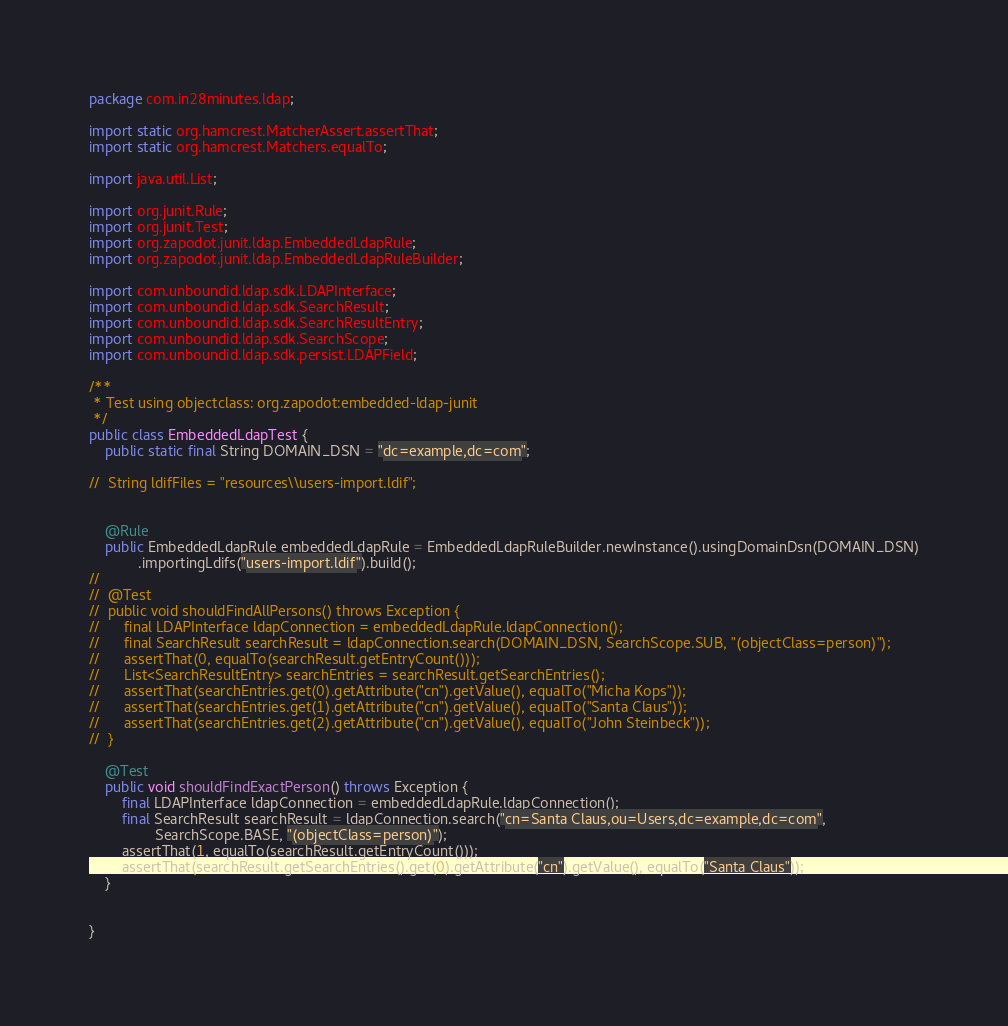Convert code to text. <code><loc_0><loc_0><loc_500><loc_500><_Java_>package com.in28minutes.ldap;

import static org.hamcrest.MatcherAssert.assertThat;
import static org.hamcrest.Matchers.equalTo;

import java.util.List;

import org.junit.Rule;
import org.junit.Test;
import org.zapodot.junit.ldap.EmbeddedLdapRule;
import org.zapodot.junit.ldap.EmbeddedLdapRuleBuilder;

import com.unboundid.ldap.sdk.LDAPInterface;
import com.unboundid.ldap.sdk.SearchResult;
import com.unboundid.ldap.sdk.SearchResultEntry;
import com.unboundid.ldap.sdk.SearchScope;
import com.unboundid.ldap.sdk.persist.LDAPField;

/**
 * Test using objectclass: org.zapodot:embedded-ldap-junit
 */
public class EmbeddedLdapTest {
	public static final String DOMAIN_DSN = "dc=example,dc=com";
	
//	String ldifFiles = "resources\\users-import.ldif";
	
	
	@Rule
	public EmbeddedLdapRule embeddedLdapRule = EmbeddedLdapRuleBuilder.newInstance().usingDomainDsn(DOMAIN_DSN)
			.importingLdifs("users-import.ldif").build();
//
//	@Test
//	public void shouldFindAllPersons() throws Exception {
//		final LDAPInterface ldapConnection = embeddedLdapRule.ldapConnection();
//		final SearchResult searchResult = ldapConnection.search(DOMAIN_DSN, SearchScope.SUB, "(objectClass=person)");
//		assertThat(0, equalTo(searchResult.getEntryCount()));
//		List<SearchResultEntry> searchEntries = searchResult.getSearchEntries();
//		assertThat(searchEntries.get(0).getAttribute("cn").getValue(), equalTo("Micha Kops"));
//		assertThat(searchEntries.get(1).getAttribute("cn").getValue(), equalTo("Santa Claus"));
//		assertThat(searchEntries.get(2).getAttribute("cn").getValue(), equalTo("John Steinbeck"));
//	}

	@Test
	public void shouldFindExactPerson() throws Exception {
		final LDAPInterface ldapConnection = embeddedLdapRule.ldapConnection();
		final SearchResult searchResult = ldapConnection.search("cn=Santa Claus,ou=Users,dc=example,dc=com",
				SearchScope.BASE, "(objectClass=person)");
		assertThat(1, equalTo(searchResult.getEntryCount()));
		assertThat(searchResult.getSearchEntries().get(0).getAttribute("cn").getValue(), equalTo("Santa Claus"));
	}
	

}</code> 